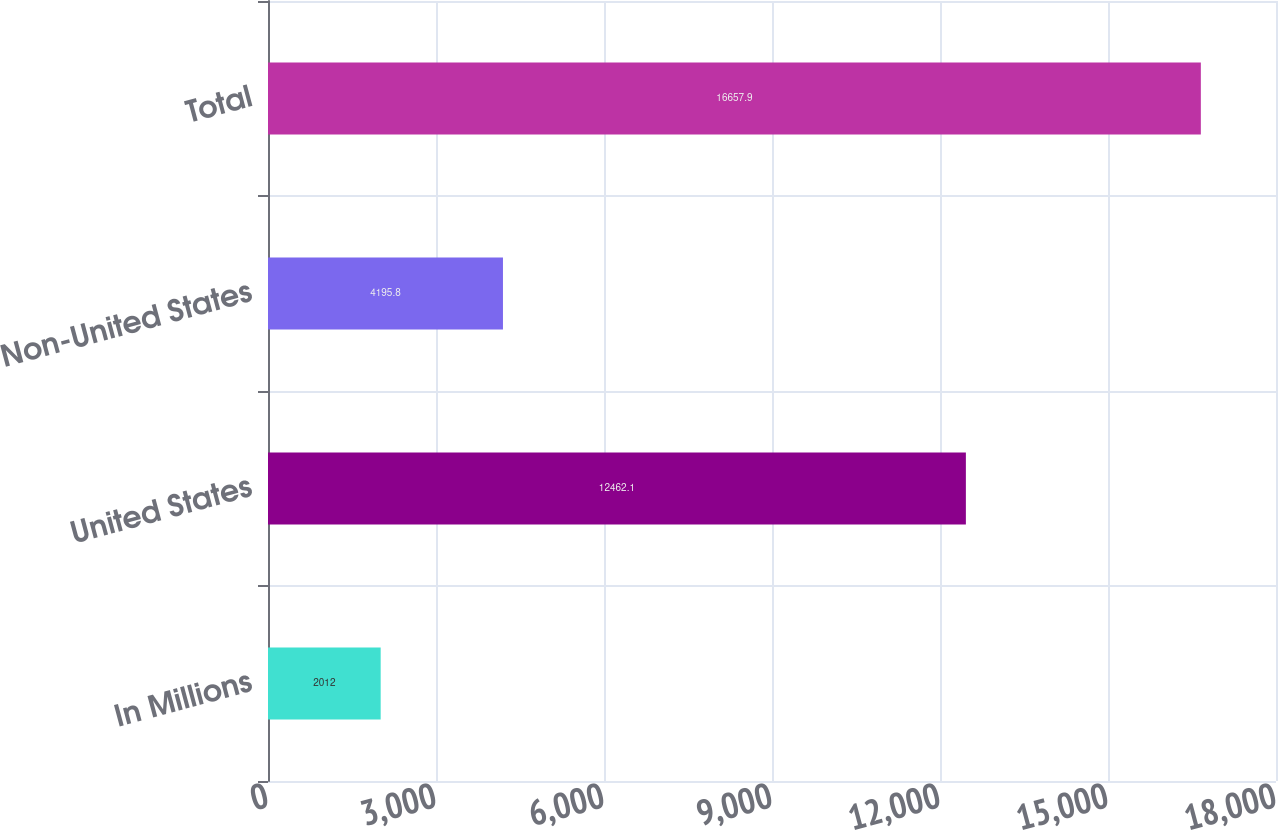<chart> <loc_0><loc_0><loc_500><loc_500><bar_chart><fcel>In Millions<fcel>United States<fcel>Non-United States<fcel>Total<nl><fcel>2012<fcel>12462.1<fcel>4195.8<fcel>16657.9<nl></chart> 